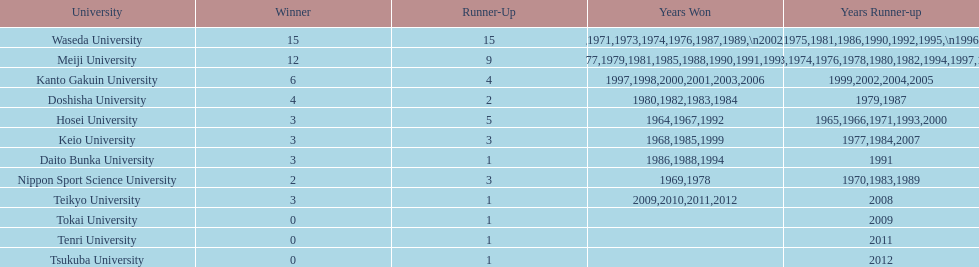Who was the victor in 1965, following hosei's triumph in 1964? Waseda University. 